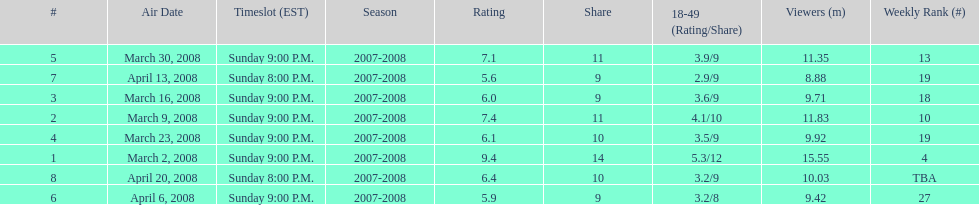How many shows had more than 10 million viewers? 4. 